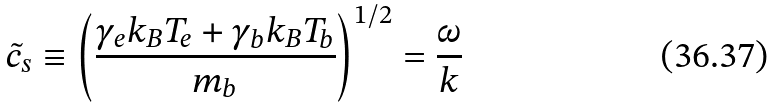<formula> <loc_0><loc_0><loc_500><loc_500>\tilde { c } _ { s } \equiv \left ( \frac { \gamma _ { e } k _ { B } T _ { e } + \gamma _ { b } k _ { B } T _ { b } } { m _ { b } } \right ) ^ { 1 / 2 } = \frac { \omega } { k }</formula> 